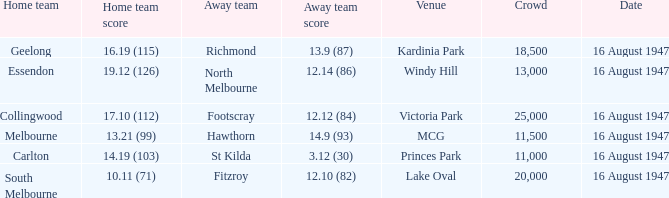What was the total size of the crowd when the away team scored 12.10 (82)? 20000.0. 